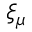<formula> <loc_0><loc_0><loc_500><loc_500>\xi _ { \mu }</formula> 